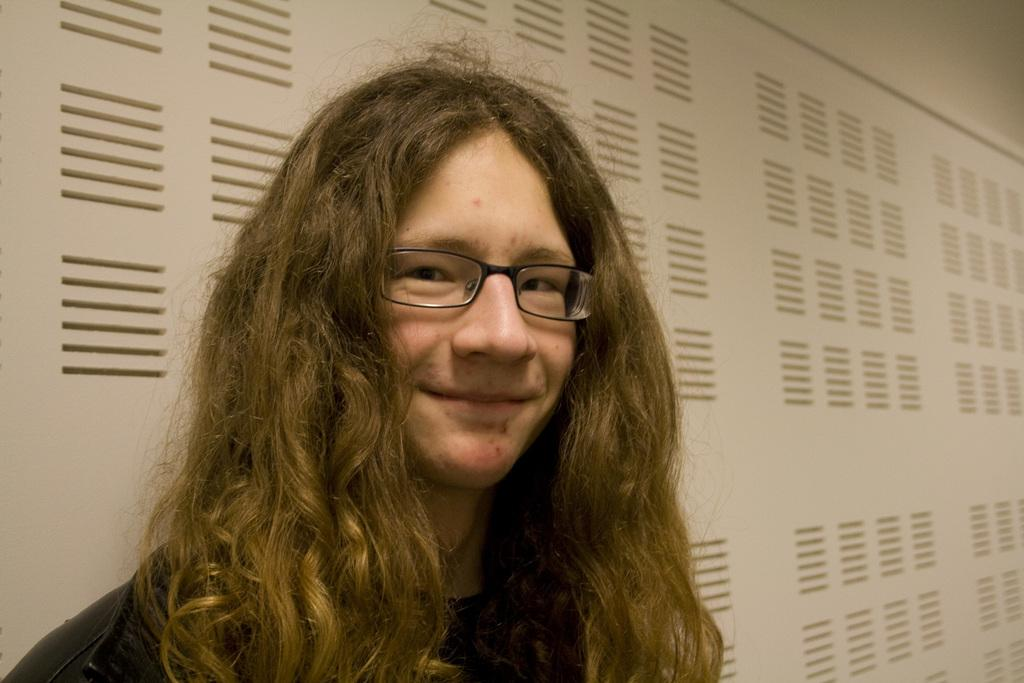Who is present in the image? There is a woman in the image. What is the woman wearing? The woman is wearing spectacles. What can be seen on the wall in the background of the image? There is a big board on the wall in the background of the image. What type of division is the woman performing in the image? There is no indication in the image that the woman is performing any division or mathematical operation. 